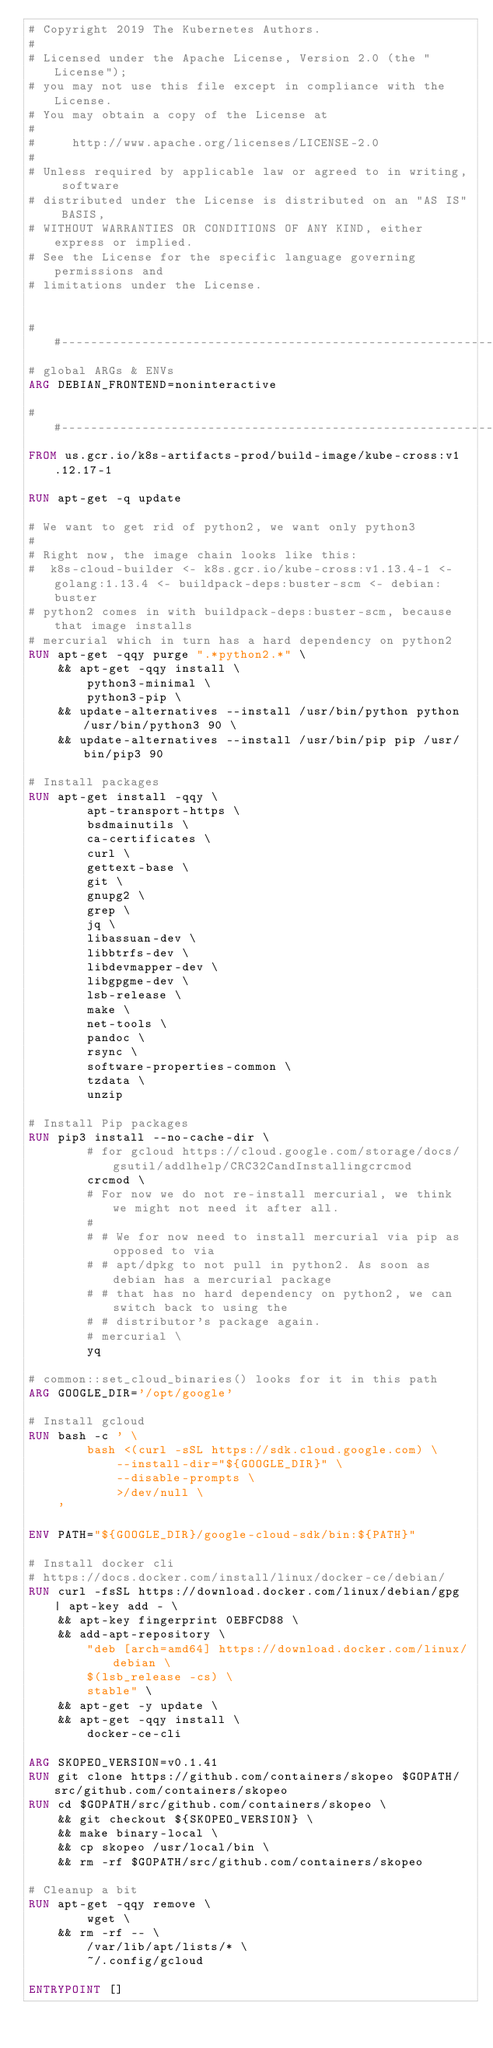Convert code to text. <code><loc_0><loc_0><loc_500><loc_500><_Dockerfile_># Copyright 2019 The Kubernetes Authors.
#
# Licensed under the Apache License, Version 2.0 (the "License");
# you may not use this file except in compliance with the License.
# You may obtain a copy of the License at
#
#     http://www.apache.org/licenses/LICENSE-2.0
#
# Unless required by applicable law or agreed to in writing, software
# distributed under the License is distributed on an "AS IS" BASIS,
# WITHOUT WARRANTIES OR CONDITIONS OF ANY KIND, either express or implied.
# See the License for the specific language governing permissions and
# limitations under the License.


##------------------------------------------------------------
# global ARGs & ENVs
ARG DEBIAN_FRONTEND=noninteractive

##------------------------------------------------------------
FROM us.gcr.io/k8s-artifacts-prod/build-image/kube-cross:v1.12.17-1

RUN apt-get -q update

# We want to get rid of python2, we want only python3
#
# Right now, the image chain looks like this:
#  k8s-cloud-builder <- k8s.gcr.io/kube-cross:v1.13.4-1 <- golang:1.13.4 <- buildpack-deps:buster-scm <- debian:buster
# python2 comes in with buildpack-deps:buster-scm, because that image installs
# mercurial which in turn has a hard dependency on python2
RUN apt-get -qqy purge ".*python2.*" \
    && apt-get -qqy install \
        python3-minimal \
        python3-pip \
    && update-alternatives --install /usr/bin/python python /usr/bin/python3 90 \
    && update-alternatives --install /usr/bin/pip pip /usr/bin/pip3 90

# Install packages
RUN apt-get install -qqy \
        apt-transport-https \
        bsdmainutils \
        ca-certificates \
        curl \
        gettext-base \
        git \
        gnupg2 \
        grep \
        jq \
        libassuan-dev \
        libbtrfs-dev \
        libdevmapper-dev \
        libgpgme-dev \
        lsb-release \
        make \
        net-tools \
        pandoc \
        rsync \
        software-properties-common \
        tzdata \
        unzip

# Install Pip packages
RUN pip3 install --no-cache-dir \
        # for gcloud https://cloud.google.com/storage/docs/gsutil/addlhelp/CRC32CandInstallingcrcmod
        crcmod \
        # For now we do not re-install mercurial, we think we might not need it after all.
        #
        # # We for now need to install mercurial via pip as opposed to via
        # # apt/dpkg to not pull in python2. As soon as debian has a mercurial package
        # # that has no hard dependency on python2, we can switch back to using the
        # # distributor's package again.
        # mercurial \
        yq

# common::set_cloud_binaries() looks for it in this path
ARG GOOGLE_DIR='/opt/google'

# Install gcloud
RUN bash -c ' \
        bash <(curl -sSL https://sdk.cloud.google.com) \
            --install-dir="${GOOGLE_DIR}" \
            --disable-prompts \
            >/dev/null \
    '

ENV PATH="${GOOGLE_DIR}/google-cloud-sdk/bin:${PATH}"

# Install docker cli
# https://docs.docker.com/install/linux/docker-ce/debian/
RUN curl -fsSL https://download.docker.com/linux/debian/gpg | apt-key add - \
    && apt-key fingerprint 0EBFCD88 \
    && add-apt-repository \
        "deb [arch=amd64] https://download.docker.com/linux/debian \
        $(lsb_release -cs) \
        stable" \
    && apt-get -y update \
    && apt-get -qqy install \
        docker-ce-cli

ARG SKOPEO_VERSION=v0.1.41
RUN git clone https://github.com/containers/skopeo $GOPATH/src/github.com/containers/skopeo
RUN cd $GOPATH/src/github.com/containers/skopeo \
    && git checkout ${SKOPEO_VERSION} \
    && make binary-local \
    && cp skopeo /usr/local/bin \
    && rm -rf $GOPATH/src/github.com/containers/skopeo

# Cleanup a bit
RUN apt-get -qqy remove \
        wget \
    && rm -rf -- \
        /var/lib/apt/lists/* \
        ~/.config/gcloud

ENTRYPOINT []
</code> 